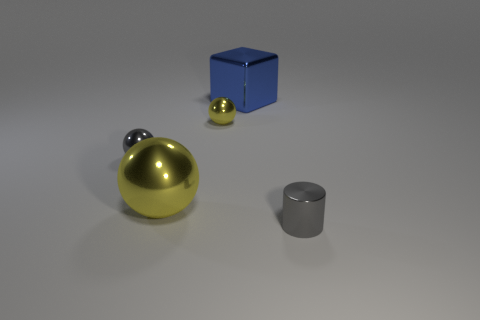Add 3 big blue objects. How many objects exist? 8 Subtract all blocks. How many objects are left? 4 Subtract 0 red cylinders. How many objects are left? 5 Subtract all tiny red rubber objects. Subtract all small yellow spheres. How many objects are left? 4 Add 4 small gray cylinders. How many small gray cylinders are left? 5 Add 4 tiny shiny objects. How many tiny shiny objects exist? 7 